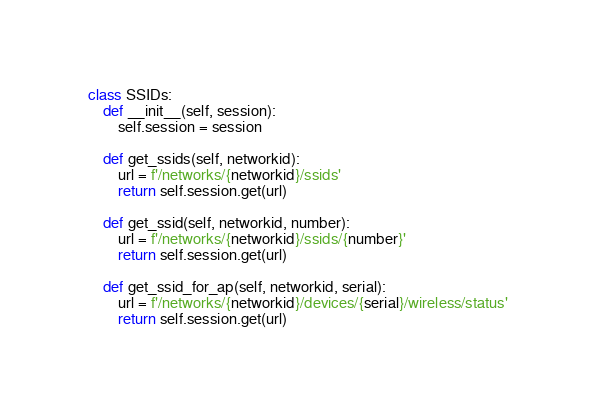Convert code to text. <code><loc_0><loc_0><loc_500><loc_500><_Python_>class SSIDs:
    def __init__(self, session):
        self.session = session

    def get_ssids(self, networkid):
        url = f'/networks/{networkid}/ssids'
        return self.session.get(url)

    def get_ssid(self, networkid, number):
        url = f'/networks/{networkid}/ssids/{number}'
        return self.session.get(url)

    def get_ssid_for_ap(self, networkid, serial):
        url = f'/networks/{networkid}/devices/{serial}/wireless/status'
        return self.session.get(url)
</code> 